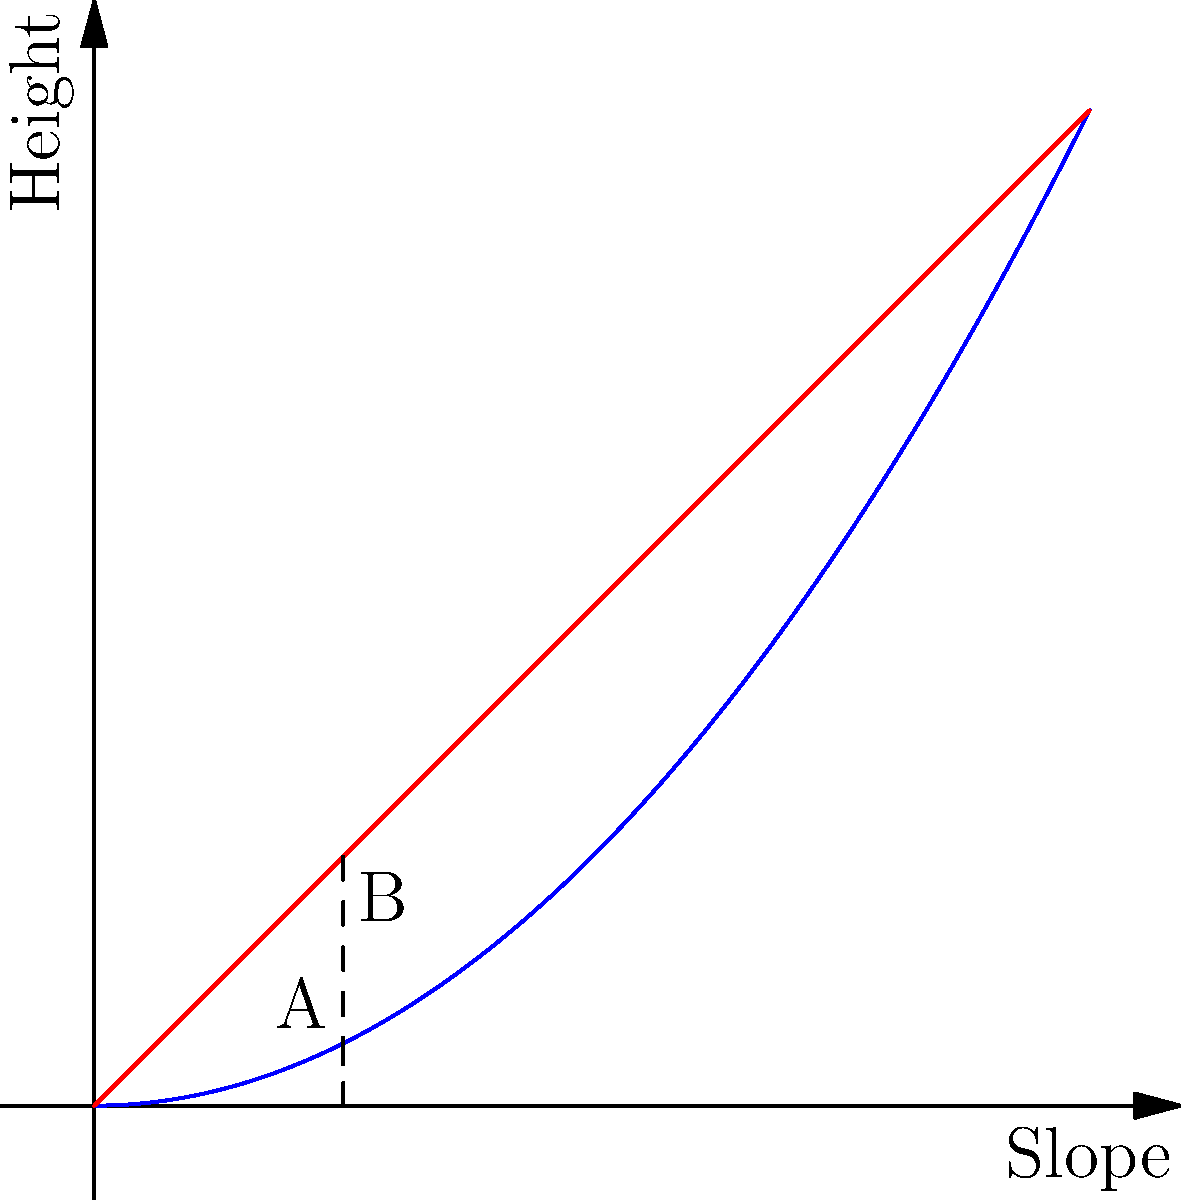Based on Jean Pontier's expertise in vineyard management, which terrace shape (A or B) would be most effective for erosion control and water management on the slopes of Tournon-sur-Rhône? To answer this question, we need to consider the properties of each terrace shape:

1. Shape A (blue curve) represents a concave terrace profile.
2. Shape B (red line) represents a linear terrace profile.

Step 1: Analyze water flow
- Concave shape (A) slows down water as it moves downslope, reducing erosion.
- Linear shape (B) maintains constant water speed, potentially causing more erosion.

Step 2: Consider soil retention
- Concave shape (A) has a gentler slope at the bottom, helping to retain soil.
- Linear shape (B) has a constant slope, which may lead to more soil loss.

Step 3: Evaluate planting area
- Concave shape (A) provides more usable planting area at the bottom of the terrace.
- Linear shape (B) offers consistent planting area throughout.

Step 4: Assess ease of maintenance
- Concave shape (A) may be slightly more challenging to maintain due to its curved profile.
- Linear shape (B) is simpler to maintain but less effective for erosion control.

Step 5: Consider local conditions
- Tournon-sur-Rhône has steep slopes and receives significant rainfall.
- Erosion control and water management are crucial for vineyard sustainability.

Given these factors, the concave shape (A) would be most effective for erosion control and water management in Tournon-sur-Rhône's vineyards.
Answer: Shape A (concave) 